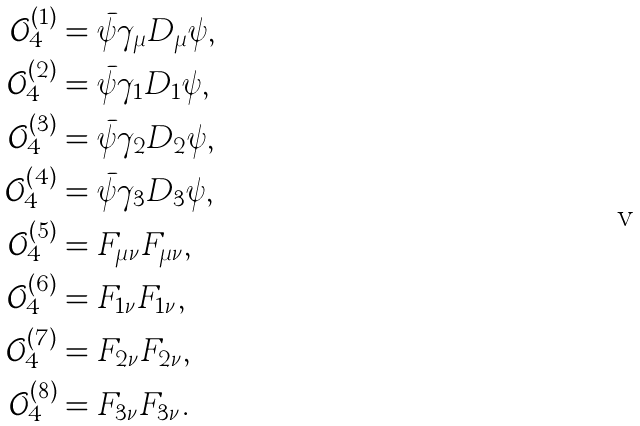Convert formula to latex. <formula><loc_0><loc_0><loc_500><loc_500>\mathcal { O } _ { 4 } ^ { ( 1 ) } & = \bar { \psi } \gamma _ { \mu } D _ { \mu } \psi , \\ \mathcal { O } _ { 4 } ^ { ( 2 ) } & = \bar { \psi } \gamma _ { 1 } D _ { 1 } \psi , \\ \mathcal { O } _ { 4 } ^ { ( 3 ) } & = \bar { \psi } \gamma _ { 2 } D _ { 2 } \psi , \\ \mathcal { O } _ { 4 } ^ { ( 4 ) } & = \bar { \psi } \gamma _ { 3 } D _ { 3 } \psi , \\ \mathcal { O } _ { 4 } ^ { ( 5 ) } & = F _ { \mu \nu } F _ { \mu \nu } , \\ \mathcal { O } _ { 4 } ^ { ( 6 ) } & = F _ { 1 \nu } F _ { 1 \nu } , \\ \mathcal { O } _ { 4 } ^ { ( 7 ) } & = F _ { 2 \nu } F _ { 2 \nu } , \\ \mathcal { O } _ { 4 } ^ { ( 8 ) } & = F _ { 3 \nu } F _ { 3 \nu } .</formula> 